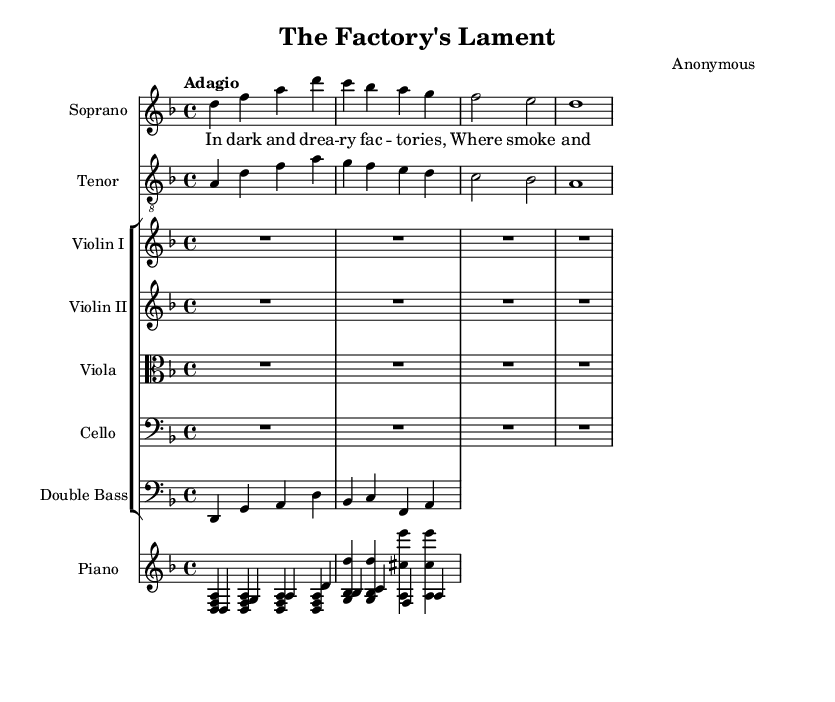What is the key signature of this music? The key signature is indicated in the beginning of the sheet music. In this case, it shows that there are two flats, which corresponds to D minor.
Answer: D minor What is the time signature of this piece? The time signature is displayed at the beginning of the score, showing a 4 over 4 notation, indicating four beats in each measure.
Answer: 4/4 What is the tempo marking of this piece? The tempo marking is found near the top of the score, stating "Adagio," which indicates a slow and leisurely tempo.
Answer: Adagio How many staves are present for the string instruments? By counting the staves in the orchestration section, there are five staves for the string instruments: Violin I, Violin II, Viola, Cello, and Double Bass.
Answer: Five What vocal parts are included in this piece? The score lists two vocal parts at the top: Soprano and Tenor, which are indicated in their respective staves.
Answer: Soprano and Tenor What is the title of this opera? The title appears at the top of the sheet music under the header section, identifying it as "The Factory's Lament."
Answer: The Factory's Lament What message do the lyrics convey about the workers? The lyrics express a somber theme about the hardships faced by workers in factories, indicating their dissatisfaction and suffering.
Answer: Misery 